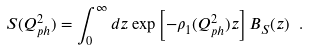<formula> <loc_0><loc_0><loc_500><loc_500>S ( Q _ { p h } ^ { 2 } ) = \int _ { 0 } ^ { \infty } d z \exp \left [ - { \rho } _ { 1 } ( Q _ { p h } ^ { 2 } ) z \right ] B _ { S } ( z ) \ .</formula> 